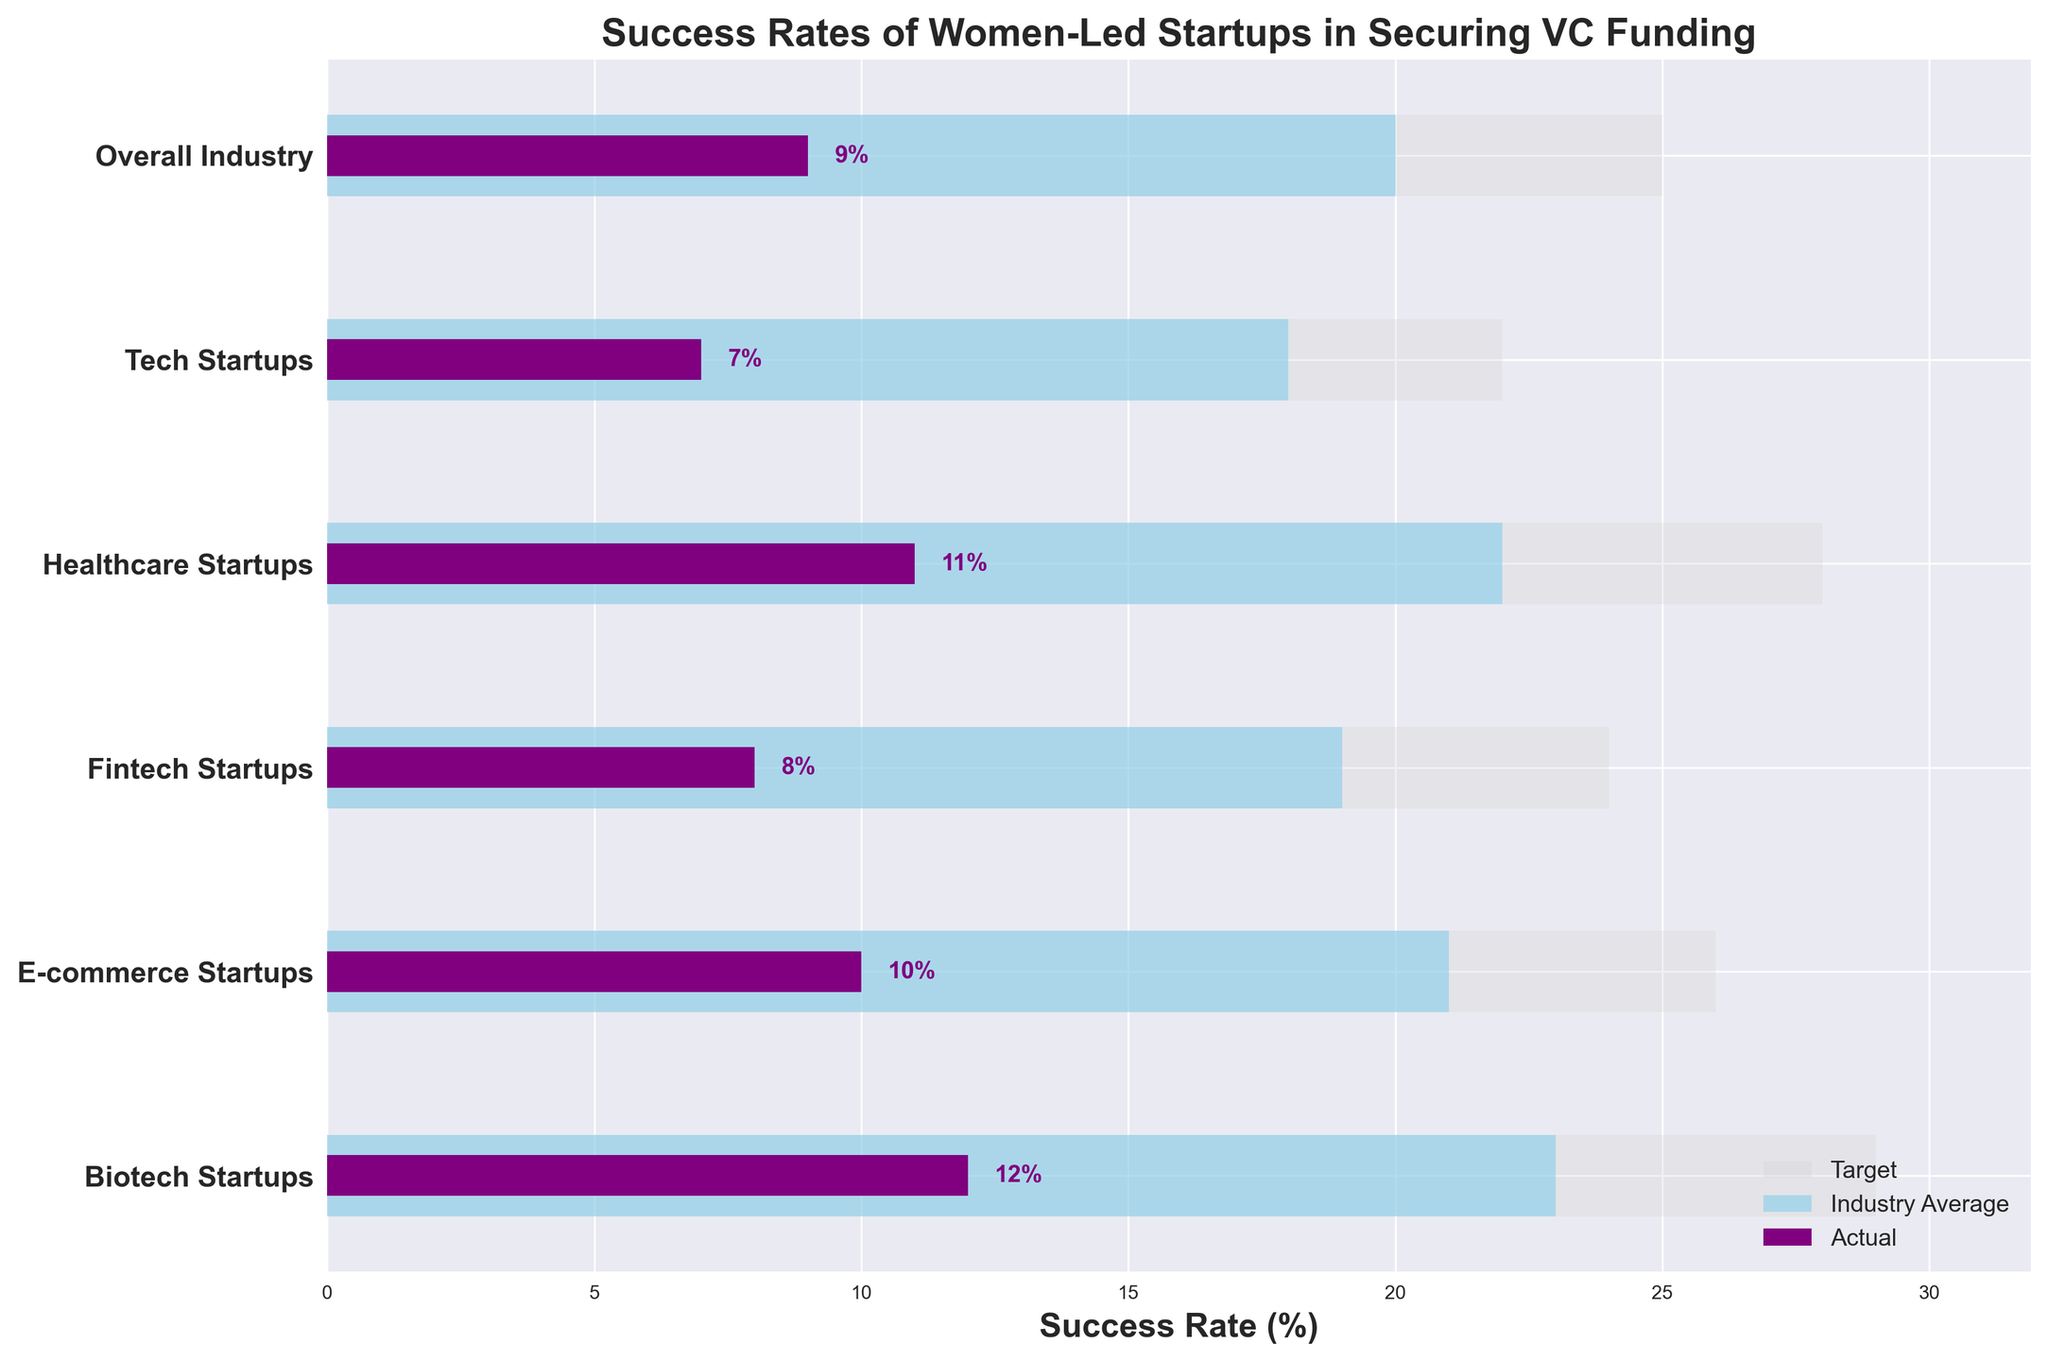What's the title of the figure? The title is usually at the top of a plot and provides a summary of what the figure represents. In this particular plot, it reads "Success Rates of Women-Led Startups in Securing VC Funding".
Answer: Success Rates of Women-Led Startups in Securing VC Funding What color represents the actual success rates of women-led startups? The actual success rates are typically indicated by the bar colors in a bullet chart. In this figure, the actual values are shown in purple.
Answer: Purple Which category has the highest actual success rate? To determine the category with the highest actual success rate, we can compare the values of the "Actual" bars. The highest actual value is 12% for Biotech Startups.
Answer: Biotech Startups How does the actual success rate for Tech Startups compare to their industry average? The actual success rate for Tech Startups is 7%, while the industry average (comparative) is 18%. Comparing these values, Tech Startups have a significantly lower actual success rate compared to their industry average.
Answer: Lower Which category has the smallest gap between actual success rate and target rate? To find the smallest gap, we will subtract the actual success rate from the target rate for each category. The gaps are: Overall Industry (25 - 9 = 16), Tech Startups (22 - 7 = 15), Healthcare Startups (28 - 11 = 17), Fintech Startups (24 - 8 = 16), E-commerce Startups (26 - 10 = 16), and Biotech Startups (29 - 12 = 17). The smallest gap is 15 for Tech Startups.
Answer: Tech Startups What's the difference between the target rate and the actual success rate in the Healthcare Startups category? The difference can be found by subtracting the actual rate from the target rate for Healthcare Startups: 28 - 11 = 17.
Answer: 17 What is the average of the actual success rates across all categories? To find the average, we sum the actual success rates and divide by the number of categories: (9 + 7 + 11 + 8 + 10 + 12) / 6 = 57 / 6 = 9.5%.
Answer: 9.5% Which category comes closest to meeting the industry average but still falls short? We must find the difference between each category's actual rate and its comparative rate and identify the smallest positive gap. The differences are: Overall Industry (20 - 9 = 11), Tech Startups (18 - 7 = 11), Healthcare Startups (22 - 11 = 11), Fintech Startups (19 - 8 = 11), E-commerce Startups (21 - 10 = 11), Biotech Startups (23 - 12 = 11). Since the smallest positive difference is the same (11%) for all categories, it indicates they all fall short by the same margin relative to their industry averages.
Answer: All categories equally When comparing the target success rate against the actual success rate, which category shows the greatest shortfall? To find the greatest shortfall, subtract the actual success rate from the target rate for each category and identify the largest value: Overall Industry (25 - 9 = 16), Tech Startups (22 - 7 = 15), Healthcare Startups (28 - 11 = 17), Fintech Startups (24 - 8 = 16), E-commerce Startups (26 - 10 = 16), Biotech Startups (29 - 12 = 17). The greatest shortfall is 17 for Healthcare Startups and Biotech Startups.
Answer: Healthcare Startups and Biotech Startups How does the overall industry target rate compare to the actual success rate for women-led startups in E-commerce? The overall industry target rate is 25%, while the actual success rate for women-led startups in E-commerce is 10%. The overall industry target rate is higher by 15%.
Answer: Higher by 15% 